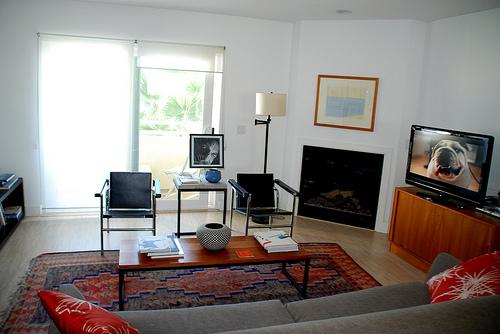Question: where is the lamp?
Choices:
A. In the corner.
B. On the table.
C. Behind the chair.
D. Near the television.
Answer with the letter. Answer: C Question: what is on the television?
Choices:
A. A dog.
B. Cat.
C. Frog.
D. Fish.
Answer with the letter. Answer: A Question: how many pillows?
Choices:
A. Three.
B. Two.
C. Four.
D. Five.
Answer with the letter. Answer: B Question: what is under the table?
Choices:
A. A cat.
B. A box.
C. Papers.
D. A rug.
Answer with the letter. Answer: D 